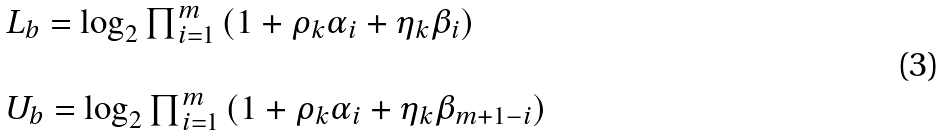<formula> <loc_0><loc_0><loc_500><loc_500>\begin{array} { l l l } L _ { b } = \log _ { 2 } \prod _ { i = 1 } ^ { m } \left ( 1 + \rho _ { k } \alpha _ { i } + \eta _ { k } \beta _ { i } \right ) \\ \\ U _ { b } = \log _ { 2 } \prod _ { i = 1 } ^ { m } \left ( 1 + \rho _ { k } \alpha _ { i } + \eta _ { k } \beta _ { m + 1 - i } \right ) \end{array}</formula> 